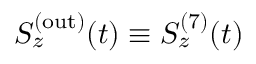Convert formula to latex. <formula><loc_0><loc_0><loc_500><loc_500>S _ { z } ^ { ( o u t ) } ( t ) \equiv S _ { z } ^ { ( 7 ) } ( t )</formula> 